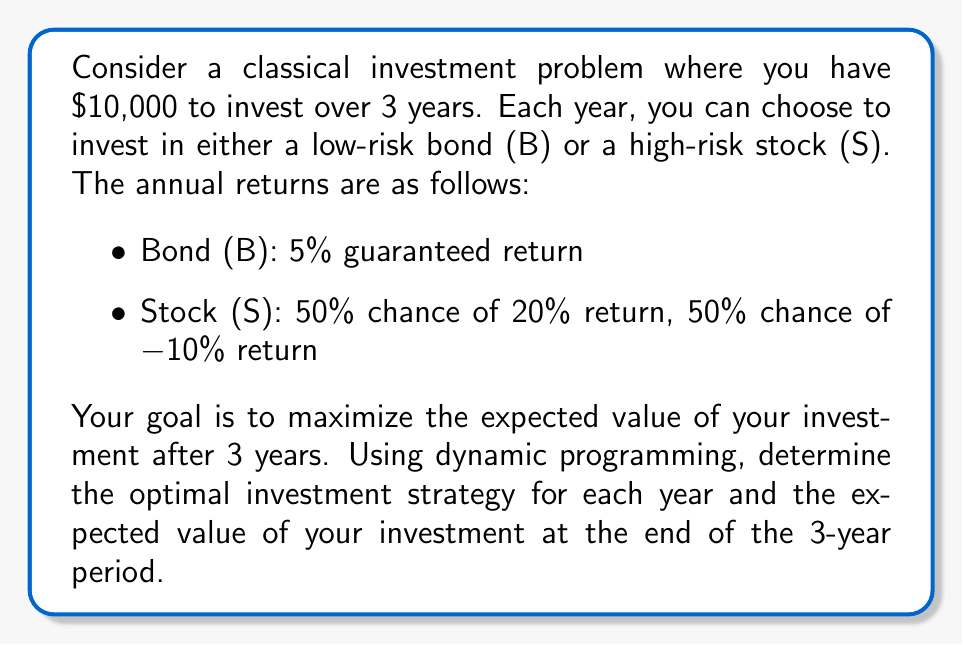Show me your answer to this math problem. Let's approach this problem using dynamic programming, working backwards from the final year to the first year.

Step 1: Define the state and decision variables
- State variable: $x_t$ = amount of money at the beginning of year $t$
- Decision variable: $d_t$ = investment decision at year $t$ (B or S)

Step 2: Define the value function
Let $V_t(x_t)$ be the maximum expected value of the investment from year $t$ to the end, given $x_t$ at the beginning of year $t$.

Step 3: Formulate the Bellman equation
For $t = 1, 2, 3$:
$$V_t(x_t) = \max\{E[V_{t+1}(1.05x_t)], E[V_{t+1}(1.2x_t)] \cdot 0.5 + E[V_{t+1}(0.9x_t)] \cdot 0.5\}$$
where $V_4(x_4) = x_4$ (terminal condition)

Step 4: Solve the problem backwards

Year 3 ($t = 3$):
$$V_3(x_3) = \max\{1.05x_3, 1.2x_3 \cdot 0.5 + 0.9x_3 \cdot 0.5\} = \max\{1.05x_3, 1.05x_3\} = 1.05x_3$$
Optimal decision: Bond (B)

Year 2 ($t = 2$):
$$V_2(x_2) = \max\{1.05 \cdot 1.05x_2, (1.2 \cdot 1.05x_2 \cdot 0.5 + 0.9 \cdot 1.05x_2 \cdot 0.5)\} = \max\{1.1025x_2, 1.1025x_2\} = 1.1025x_2$$
Optimal decision: Either Bond (B) or Stock (S)

Year 1 ($t = 1$):
$$V_1(x_1) = \max\{1.1025 \cdot 1.05x_1, (1.2 \cdot 1.1025x_1 \cdot 0.5 + 0.9 \cdot 1.1025x_1 \cdot 0.5)\} = \max\{1.157625x_1, 1.157625x_1\} = 1.157625x_1$$
Optimal decision: Either Bond (B) or Stock (S)

Step 5: Determine the optimal strategy and expected value
The optimal strategy is to choose either Bond (B) or Stock (S) in years 1 and 2, and Bond (B) in year 3.

The expected value of the investment after 3 years is:
$$V_1(10000) = 1.157625 \cdot 10000 = 11576.25$$
Answer: The optimal investment strategy is to choose either Bond (B) or Stock (S) in years 1 and 2, and Bond (B) in year 3. The expected value of the investment after 3 years is $11,576.25. 